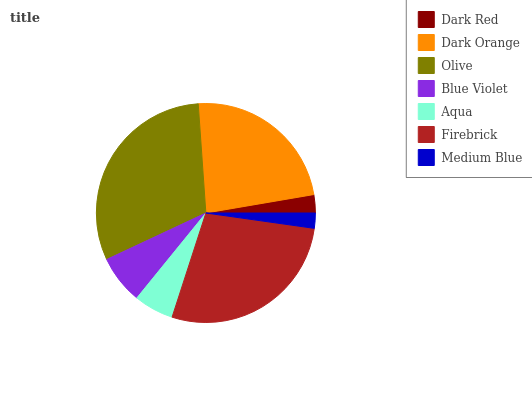Is Medium Blue the minimum?
Answer yes or no. Yes. Is Olive the maximum?
Answer yes or no. Yes. Is Dark Orange the minimum?
Answer yes or no. No. Is Dark Orange the maximum?
Answer yes or no. No. Is Dark Orange greater than Dark Red?
Answer yes or no. Yes. Is Dark Red less than Dark Orange?
Answer yes or no. Yes. Is Dark Red greater than Dark Orange?
Answer yes or no. No. Is Dark Orange less than Dark Red?
Answer yes or no. No. Is Blue Violet the high median?
Answer yes or no. Yes. Is Blue Violet the low median?
Answer yes or no. Yes. Is Aqua the high median?
Answer yes or no. No. Is Firebrick the low median?
Answer yes or no. No. 